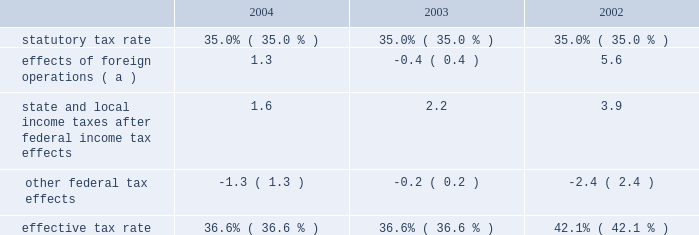Gain or loss on ownership change in map results from contributions to map of certain environmental capital expenditures and leased property acquisitions funded by marathon and ashland .
In accordance with map 2019s limited liability company agreement , in certain instances , environmental capital expenditures and acquisitions of leased properties are funded by the original contributor of the assets , but no change in ownership interest may result from these contributions .
An excess of ashland funded improvements over marathon funded improvements results in a net gain and an excess of marathon funded improvements over ashland funded improvements results in a net loss .
Cost of revenues increased by $ 5.822 billion in 2004 from 2003 and by $ 6.040 billion in 2003 from 2002 .
The increases are primarily in the rm&t segment and result from higher acquisition costs for crude oil , refined products , refinery charge and blend feedstocks and increased manufacturing expenses .
Selling , general and administrative expenses increased by $ 105 million in 2004 from 2003 and by $ 97 million in 2003 from 2002 .
The increase in 2004 was primarily due to increased stock-based compensation and higher costs associated with business transformation and outsourcing .
Our 2004 results were also impacted by start-up costs associated with the lng project in equatorial guinea and the increased cost of complying with governmental regulations .
The increase in 2003 was primarily due to increased employee benefit expenses ( caused by increased pension expense resulting from changes in actuarial assumptions and a decrease in realized returns on plan assets ) and other employee related costs .
Additionally , during 2003 , we recorded a charge of $ 24 million related to organizational and business process changes .
Inventory market valuation reserve ( 2018 2018imv 2019 2019 ) is established to reduce the cost basis of inventories to current market value .
Generally , we will establish an imv reserve when crude oil prices fall below $ 22 per barrel .
The 2002 results of operations include credits to income from operations of $ 71 million , reversing the imv reserve at december 31 , 2001 .
Net interest and other financial costs decreased by $ 25 million in 2004 from 2003 and by $ 82 million in 2003 from 2002 .
The decrease in 2004 is primarily due to an increase in interest income .
The decrease in 2003 is primarily due to an increase in capitalized interest related to increased long-term construction projects , the favorable effect of interest rate swaps , the favorable effect of a reduction in interest on tax deficiencies and increased interest income on investments .
Additionally , included in net interest and other financing costs are foreign currency gains of $ 9 million , $ 13 million and $ 8 million for 2004 , 2003 and 2002 .
Loss from early extinguishment of debt in 2002 was attributable to the retirement of $ 337 million aggregate principal amount of debt , resulting in a loss of $ 53 million .
Minority interest in income of map , which represents ashland 2019s 38 percent ownership interest , increased by $ 230 million in 2004 from 2003 and by $ 129 million in 2003 from 2002 .
Map income was higher in 2004 compared to 2003 and in 2003 compared to 2002 as discussed below in the rm&t segment .
Minority interest in loss of equatorial guinea lng holdings limited , which represents gepetrol 2019s 25 percent ownership interest , was $ 7 million in 2004 , primarily resulting from gepetrol 2019s share of start-up costs associated with the lng project in equatorial guinea .
Provision for income taxes increased by $ 143 million in 2004 from 2003 and by $ 215 million in 2003 from 2002 , primarily due to $ 388 million and $ 720 million increases in income before income taxes .
The effective tax rate for 2004 was 36.6 percent compared to 36.6 percent and 42.1 percent for 2003 and 2002 .
The higher rate in 2002 was due to the united kingdom enactment of a supplementary 10 percent tax on profits from the north sea oil and gas production , retroactively effective to april 17 , 2002 .
In 2002 , we recognized a one-time noncash deferred tax adjustment of $ 61 million as a result of the rate increase .
The following is an analysis of the effective tax rate for the periods presented: .
( a ) the deferred tax effect related to the enactment of a supplemental tax in the u.k .
Increased the effective tax rate 7.0 percent in .
By how much did the effective tax rate decrease from 2002 to 2004? 
Computations: (36.6% - 42.1%)
Answer: -0.055. 